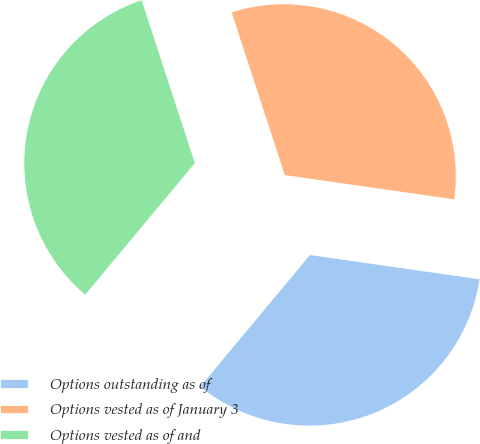Convert chart to OTSL. <chart><loc_0><loc_0><loc_500><loc_500><pie_chart><fcel>Options outstanding as of<fcel>Options vested as of January 3<fcel>Options vested as of and<nl><fcel>33.79%<fcel>32.29%<fcel>33.92%<nl></chart> 